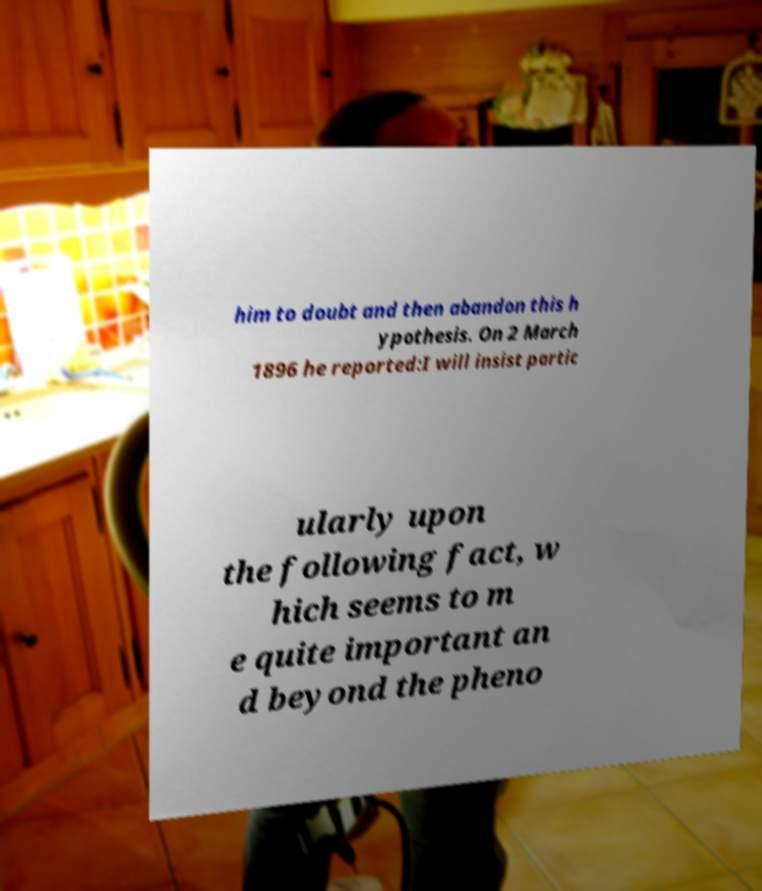For documentation purposes, I need the text within this image transcribed. Could you provide that? him to doubt and then abandon this h ypothesis. On 2 March 1896 he reported:I will insist partic ularly upon the following fact, w hich seems to m e quite important an d beyond the pheno 